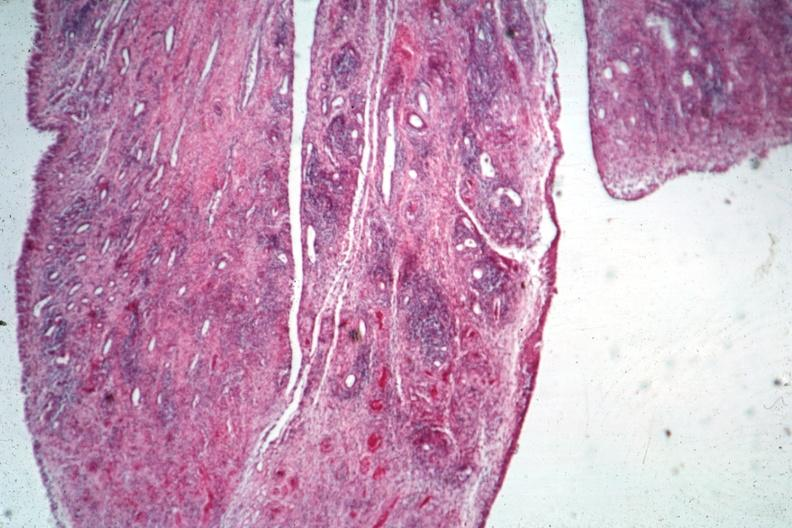what is present?
Answer the question using a single word or phrase. Joints 